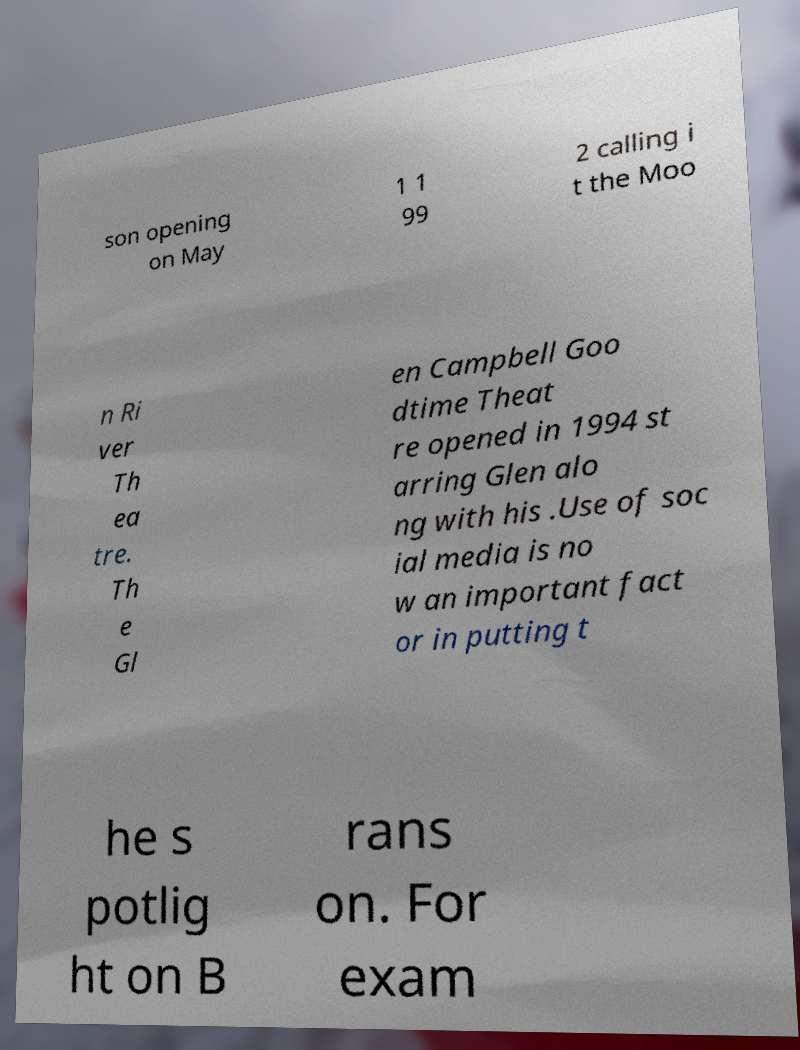Could you extract and type out the text from this image? son opening on May 1 1 99 2 calling i t the Moo n Ri ver Th ea tre. Th e Gl en Campbell Goo dtime Theat re opened in 1994 st arring Glen alo ng with his .Use of soc ial media is no w an important fact or in putting t he s potlig ht on B rans on. For exam 